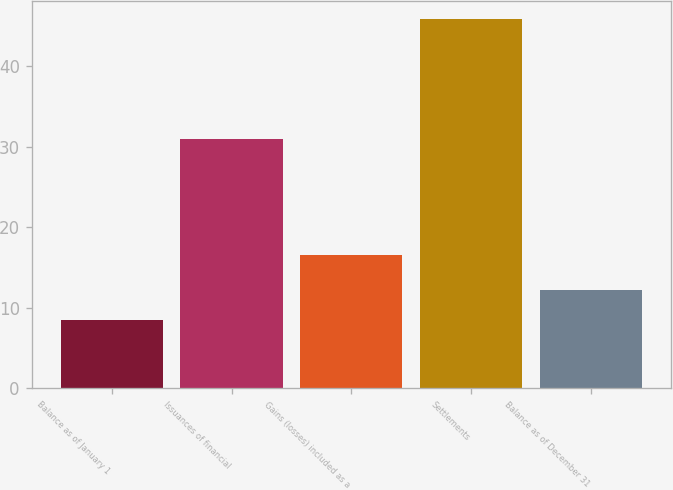Convert chart to OTSL. <chart><loc_0><loc_0><loc_500><loc_500><bar_chart><fcel>Balance as of January 1<fcel>Issuances of financial<fcel>Gains (losses) included as a<fcel>Settlements<fcel>Balance as of December 31<nl><fcel>8.5<fcel>31<fcel>16.5<fcel>45.8<fcel>12.23<nl></chart> 